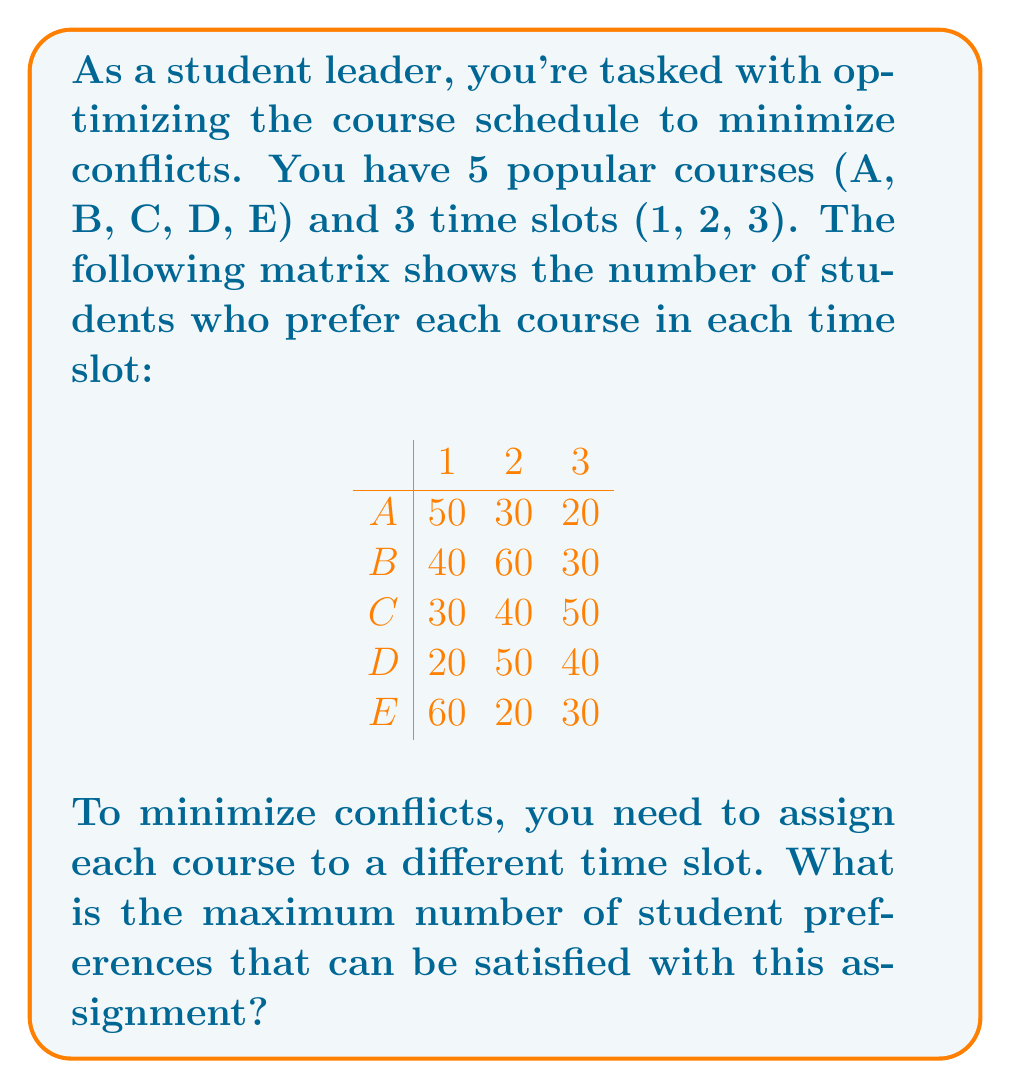What is the answer to this math problem? To solve this problem, we can use the Hungarian algorithm for maximum assignment. However, for this small problem, we can also use a systematic approach:

1) First, note that we need to choose one value from each row, and each column can only be used once.

2) The maximum possible sum will include the largest value that doesn't conflict with other large values.

3) Looking at the matrix, the largest value is 60, which appears twice: for B in slot 2 and E in slot 1.

4) If we choose B in slot 2, we can't choose the other 60 for E in slot 1. Let's explore both options:

   Option 1: B in slot 2 (60)
   - We can't use slot 2 anymore
   - For A, the best remaining is slot 1 (50)
   - For C, the best remaining is slot 3 (50)
   - For D, we're forced to use slot 1 (20)
   - For E, we're forced to use slot 3 (30)
   Total: 60 + 50 + 50 + 20 + 30 = 210

   Option 2: E in slot 1 (60)
   - We can't use slot 1 anymore
   - For A, the best remaining is slot 2 (30)
   - For B, the best remaining is slot 2 (60)
   - For C, the best remaining is slot 3 (50)
   - For D, we're forced to use slot 3 (40)
   Total: 60 + 30 + 60 + 50 + 40 = 240

5) Option 2 gives a higher total, so this is our optimal solution.

Therefore, the maximum number of student preferences that can be satisfied is 240.
Answer: 240 